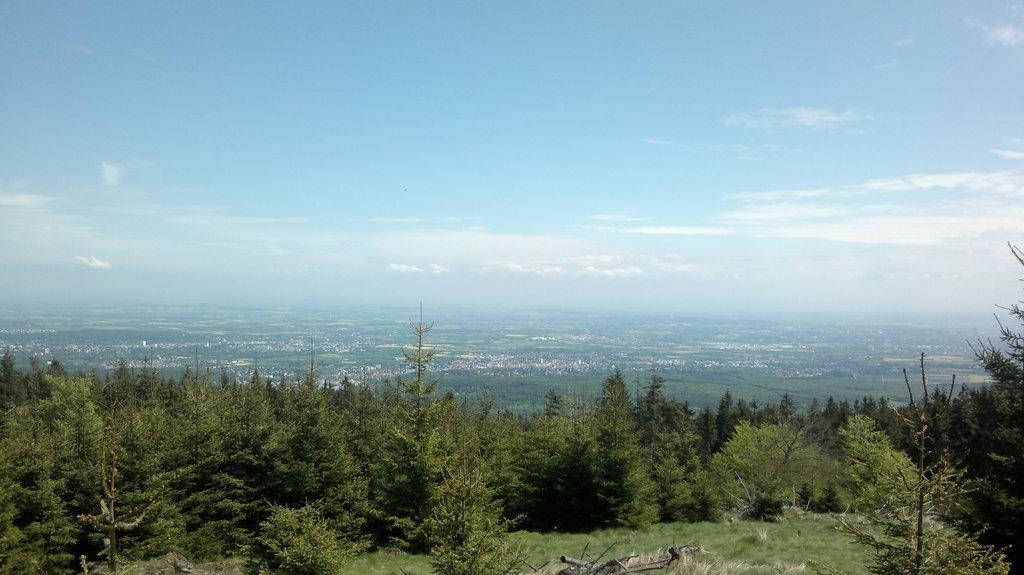How would you summarize this image in a sentence or two? In this picture we can see trees and in the background we can see the sky with clouds. 